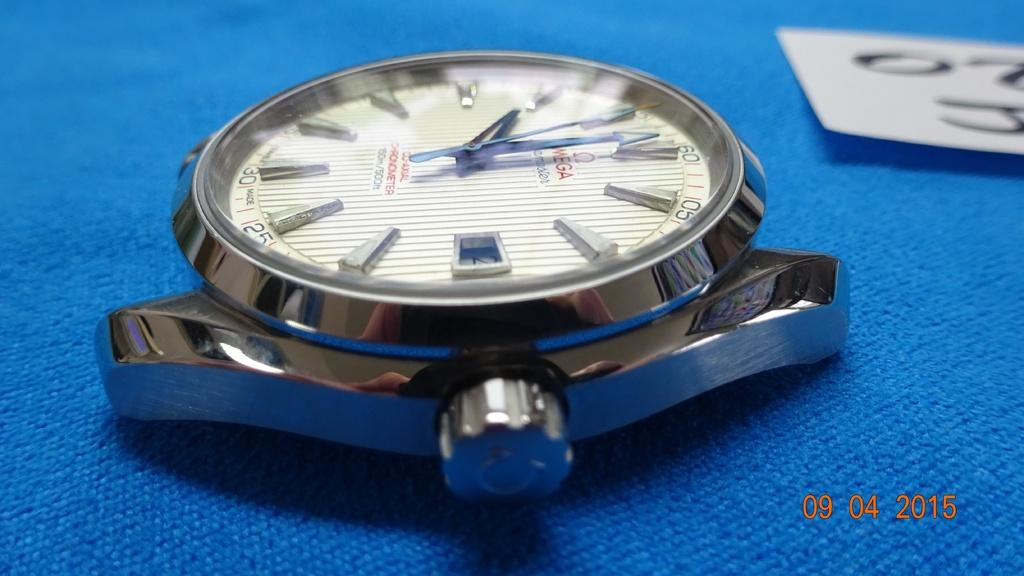<image>
Provide a brief description of the given image. A Omega watch with no wrist band laying on a blue cloth. 